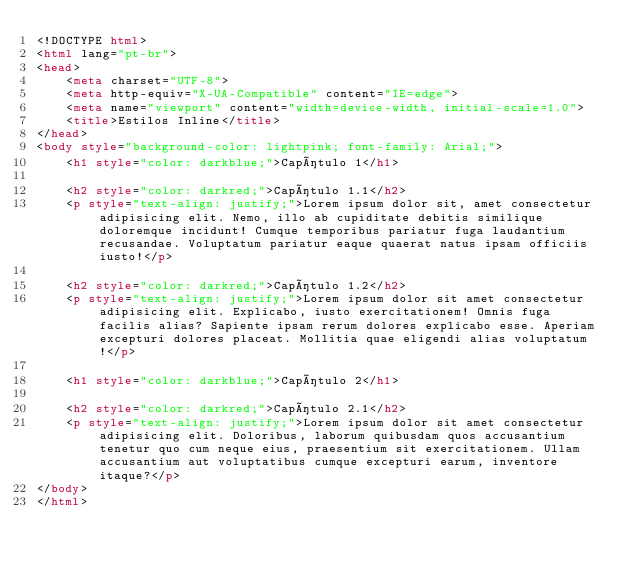Convert code to text. <code><loc_0><loc_0><loc_500><loc_500><_HTML_><!DOCTYPE html>
<html lang="pt-br">
<head>
    <meta charset="UTF-8">
    <meta http-equiv="X-UA-Compatible" content="IE=edge">
    <meta name="viewport" content="width=device-width, initial-scale=1.0">
    <title>Estilos Inline</title>
</head>
<body style="background-color: lightpink; font-family: Arial;">
    <h1 style="color: darkblue;">Capítulo 1</h1>
    
    <h2 style="color: darkred;">Capítulo 1.1</h2>
    <p style="text-align: justify;">Lorem ipsum dolor sit, amet consectetur adipisicing elit. Nemo, illo ab cupiditate debitis similique doloremque incidunt! Cumque temporibus pariatur fuga laudantium recusandae. Voluptatum pariatur eaque quaerat natus ipsam officiis iusto!</p>

    <h2 style="color: darkred;">Capítulo 1.2</h2>
    <p style="text-align: justify;">Lorem ipsum dolor sit amet consectetur adipisicing elit. Explicabo, iusto exercitationem! Omnis fuga facilis alias? Sapiente ipsam rerum dolores explicabo esse. Aperiam excepturi dolores placeat. Mollitia quae eligendi alias voluptatum!</p>

    <h1 style="color: darkblue;">Capítulo 2</h1>

    <h2 style="color: darkred;">Capítulo 2.1</h2>
    <p style="text-align: justify;">Lorem ipsum dolor sit amet consectetur adipisicing elit. Doloribus, laborum quibusdam quos accusantium tenetur quo cum neque eius, praesentium sit exercitationem. Ullam accusantium aut voluptatibus cumque excepturi earum, inventore itaque?</p>
</body>
</html></code> 